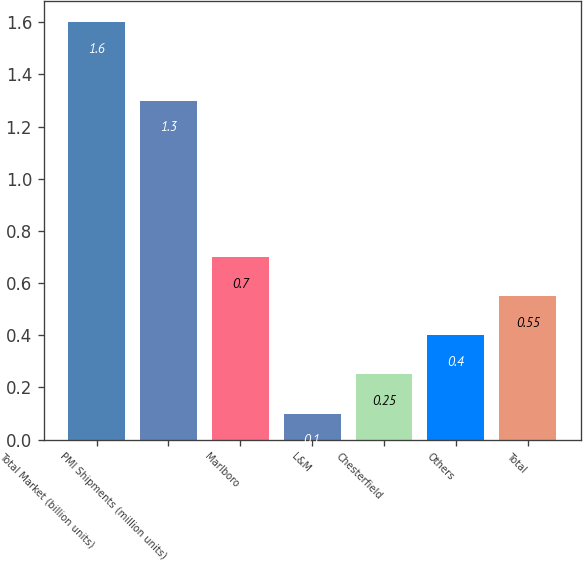Convert chart. <chart><loc_0><loc_0><loc_500><loc_500><bar_chart><fcel>Total Market (billion units)<fcel>PMI Shipments (million units)<fcel>Marlboro<fcel>L&M<fcel>Chesterfield<fcel>Others<fcel>Total<nl><fcel>1.6<fcel>1.3<fcel>0.7<fcel>0.1<fcel>0.25<fcel>0.4<fcel>0.55<nl></chart> 